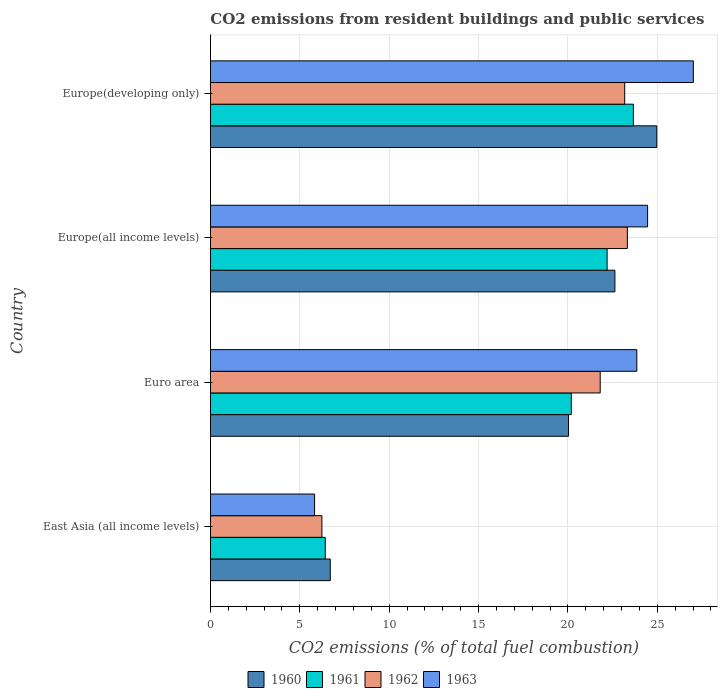How many groups of bars are there?
Provide a succinct answer. 4. Are the number of bars on each tick of the Y-axis equal?
Provide a short and direct response. Yes. What is the label of the 3rd group of bars from the top?
Make the answer very short. Euro area. What is the total CO2 emitted in 1961 in Europe(all income levels)?
Offer a terse response. 22.19. Across all countries, what is the maximum total CO2 emitted in 1963?
Make the answer very short. 27.01. Across all countries, what is the minimum total CO2 emitted in 1960?
Ensure brevity in your answer.  6.7. In which country was the total CO2 emitted in 1961 maximum?
Give a very brief answer. Europe(developing only). In which country was the total CO2 emitted in 1961 minimum?
Your response must be concise. East Asia (all income levels). What is the total total CO2 emitted in 1962 in the graph?
Offer a terse response. 74.53. What is the difference between the total CO2 emitted in 1960 in East Asia (all income levels) and that in Euro area?
Your response must be concise. -13.33. What is the difference between the total CO2 emitted in 1960 in Euro area and the total CO2 emitted in 1961 in Europe(developing only)?
Ensure brevity in your answer.  -3.63. What is the average total CO2 emitted in 1960 per country?
Provide a succinct answer. 18.58. What is the difference between the total CO2 emitted in 1960 and total CO2 emitted in 1962 in Europe(all income levels)?
Your response must be concise. -0.7. What is the ratio of the total CO2 emitted in 1960 in East Asia (all income levels) to that in Euro area?
Provide a short and direct response. 0.33. What is the difference between the highest and the second highest total CO2 emitted in 1961?
Offer a terse response. 1.47. What is the difference between the highest and the lowest total CO2 emitted in 1962?
Your response must be concise. 17.09. In how many countries, is the total CO2 emitted in 1963 greater than the average total CO2 emitted in 1963 taken over all countries?
Your response must be concise. 3. What does the 3rd bar from the top in Europe(all income levels) represents?
Offer a very short reply. 1961. How many bars are there?
Provide a succinct answer. 16. What is the difference between two consecutive major ticks on the X-axis?
Keep it short and to the point. 5. Are the values on the major ticks of X-axis written in scientific E-notation?
Offer a very short reply. No. Does the graph contain grids?
Offer a very short reply. Yes. Where does the legend appear in the graph?
Provide a succinct answer. Bottom center. How many legend labels are there?
Provide a succinct answer. 4. How are the legend labels stacked?
Keep it short and to the point. Horizontal. What is the title of the graph?
Offer a very short reply. CO2 emissions from resident buildings and public services. What is the label or title of the X-axis?
Your answer should be compact. CO2 emissions (% of total fuel combustion). What is the label or title of the Y-axis?
Your answer should be compact. Country. What is the CO2 emissions (% of total fuel combustion) of 1960 in East Asia (all income levels)?
Offer a very short reply. 6.7. What is the CO2 emissions (% of total fuel combustion) in 1961 in East Asia (all income levels)?
Offer a terse response. 6.42. What is the CO2 emissions (% of total fuel combustion) of 1962 in East Asia (all income levels)?
Make the answer very short. 6.23. What is the CO2 emissions (% of total fuel combustion) in 1963 in East Asia (all income levels)?
Your response must be concise. 5.82. What is the CO2 emissions (% of total fuel combustion) of 1960 in Euro area?
Give a very brief answer. 20.03. What is the CO2 emissions (% of total fuel combustion) of 1961 in Euro area?
Offer a terse response. 20.19. What is the CO2 emissions (% of total fuel combustion) in 1962 in Euro area?
Make the answer very short. 21.8. What is the CO2 emissions (% of total fuel combustion) in 1963 in Euro area?
Provide a short and direct response. 23.85. What is the CO2 emissions (% of total fuel combustion) in 1960 in Europe(all income levels)?
Offer a terse response. 22.63. What is the CO2 emissions (% of total fuel combustion) of 1961 in Europe(all income levels)?
Your answer should be compact. 22.19. What is the CO2 emissions (% of total fuel combustion) of 1962 in Europe(all income levels)?
Keep it short and to the point. 23.32. What is the CO2 emissions (% of total fuel combustion) of 1963 in Europe(all income levels)?
Provide a succinct answer. 24.45. What is the CO2 emissions (% of total fuel combustion) of 1960 in Europe(developing only)?
Ensure brevity in your answer.  24.97. What is the CO2 emissions (% of total fuel combustion) in 1961 in Europe(developing only)?
Your answer should be compact. 23.66. What is the CO2 emissions (% of total fuel combustion) in 1962 in Europe(developing only)?
Provide a short and direct response. 23.17. What is the CO2 emissions (% of total fuel combustion) of 1963 in Europe(developing only)?
Offer a very short reply. 27.01. Across all countries, what is the maximum CO2 emissions (% of total fuel combustion) of 1960?
Provide a succinct answer. 24.97. Across all countries, what is the maximum CO2 emissions (% of total fuel combustion) in 1961?
Your response must be concise. 23.66. Across all countries, what is the maximum CO2 emissions (% of total fuel combustion) of 1962?
Give a very brief answer. 23.32. Across all countries, what is the maximum CO2 emissions (% of total fuel combustion) of 1963?
Your answer should be very brief. 27.01. Across all countries, what is the minimum CO2 emissions (% of total fuel combustion) of 1960?
Your answer should be very brief. 6.7. Across all countries, what is the minimum CO2 emissions (% of total fuel combustion) in 1961?
Offer a terse response. 6.42. Across all countries, what is the minimum CO2 emissions (% of total fuel combustion) in 1962?
Ensure brevity in your answer.  6.23. Across all countries, what is the minimum CO2 emissions (% of total fuel combustion) in 1963?
Your answer should be very brief. 5.82. What is the total CO2 emissions (% of total fuel combustion) in 1960 in the graph?
Your answer should be compact. 74.33. What is the total CO2 emissions (% of total fuel combustion) in 1961 in the graph?
Give a very brief answer. 72.46. What is the total CO2 emissions (% of total fuel combustion) in 1962 in the graph?
Your answer should be very brief. 74.53. What is the total CO2 emissions (% of total fuel combustion) in 1963 in the graph?
Offer a terse response. 81.15. What is the difference between the CO2 emissions (% of total fuel combustion) in 1960 in East Asia (all income levels) and that in Euro area?
Make the answer very short. -13.33. What is the difference between the CO2 emissions (% of total fuel combustion) of 1961 in East Asia (all income levels) and that in Euro area?
Keep it short and to the point. -13.76. What is the difference between the CO2 emissions (% of total fuel combustion) in 1962 in East Asia (all income levels) and that in Euro area?
Ensure brevity in your answer.  -15.57. What is the difference between the CO2 emissions (% of total fuel combustion) in 1963 in East Asia (all income levels) and that in Euro area?
Keep it short and to the point. -18.03. What is the difference between the CO2 emissions (% of total fuel combustion) of 1960 in East Asia (all income levels) and that in Europe(all income levels)?
Your response must be concise. -15.92. What is the difference between the CO2 emissions (% of total fuel combustion) in 1961 in East Asia (all income levels) and that in Europe(all income levels)?
Provide a succinct answer. -15.77. What is the difference between the CO2 emissions (% of total fuel combustion) in 1962 in East Asia (all income levels) and that in Europe(all income levels)?
Provide a succinct answer. -17.09. What is the difference between the CO2 emissions (% of total fuel combustion) in 1963 in East Asia (all income levels) and that in Europe(all income levels)?
Your response must be concise. -18.63. What is the difference between the CO2 emissions (% of total fuel combustion) of 1960 in East Asia (all income levels) and that in Europe(developing only)?
Your answer should be very brief. -18.27. What is the difference between the CO2 emissions (% of total fuel combustion) in 1961 in East Asia (all income levels) and that in Europe(developing only)?
Keep it short and to the point. -17.24. What is the difference between the CO2 emissions (% of total fuel combustion) of 1962 in East Asia (all income levels) and that in Europe(developing only)?
Provide a short and direct response. -16.94. What is the difference between the CO2 emissions (% of total fuel combustion) of 1963 in East Asia (all income levels) and that in Europe(developing only)?
Keep it short and to the point. -21.19. What is the difference between the CO2 emissions (% of total fuel combustion) of 1960 in Euro area and that in Europe(all income levels)?
Your answer should be compact. -2.59. What is the difference between the CO2 emissions (% of total fuel combustion) in 1961 in Euro area and that in Europe(all income levels)?
Your answer should be very brief. -2. What is the difference between the CO2 emissions (% of total fuel combustion) of 1962 in Euro area and that in Europe(all income levels)?
Your answer should be very brief. -1.52. What is the difference between the CO2 emissions (% of total fuel combustion) in 1963 in Euro area and that in Europe(all income levels)?
Keep it short and to the point. -0.6. What is the difference between the CO2 emissions (% of total fuel combustion) of 1960 in Euro area and that in Europe(developing only)?
Provide a short and direct response. -4.94. What is the difference between the CO2 emissions (% of total fuel combustion) of 1961 in Euro area and that in Europe(developing only)?
Your response must be concise. -3.47. What is the difference between the CO2 emissions (% of total fuel combustion) of 1962 in Euro area and that in Europe(developing only)?
Give a very brief answer. -1.37. What is the difference between the CO2 emissions (% of total fuel combustion) in 1963 in Euro area and that in Europe(developing only)?
Ensure brevity in your answer.  -3.16. What is the difference between the CO2 emissions (% of total fuel combustion) of 1960 in Europe(all income levels) and that in Europe(developing only)?
Offer a terse response. -2.34. What is the difference between the CO2 emissions (% of total fuel combustion) in 1961 in Europe(all income levels) and that in Europe(developing only)?
Provide a short and direct response. -1.47. What is the difference between the CO2 emissions (% of total fuel combustion) in 1962 in Europe(all income levels) and that in Europe(developing only)?
Your answer should be compact. 0.15. What is the difference between the CO2 emissions (% of total fuel combustion) in 1963 in Europe(all income levels) and that in Europe(developing only)?
Give a very brief answer. -2.56. What is the difference between the CO2 emissions (% of total fuel combustion) in 1960 in East Asia (all income levels) and the CO2 emissions (% of total fuel combustion) in 1961 in Euro area?
Ensure brevity in your answer.  -13.48. What is the difference between the CO2 emissions (% of total fuel combustion) in 1960 in East Asia (all income levels) and the CO2 emissions (% of total fuel combustion) in 1962 in Euro area?
Your answer should be compact. -15.1. What is the difference between the CO2 emissions (% of total fuel combustion) of 1960 in East Asia (all income levels) and the CO2 emissions (% of total fuel combustion) of 1963 in Euro area?
Your answer should be compact. -17.15. What is the difference between the CO2 emissions (% of total fuel combustion) of 1961 in East Asia (all income levels) and the CO2 emissions (% of total fuel combustion) of 1962 in Euro area?
Provide a succinct answer. -15.38. What is the difference between the CO2 emissions (% of total fuel combustion) of 1961 in East Asia (all income levels) and the CO2 emissions (% of total fuel combustion) of 1963 in Euro area?
Offer a very short reply. -17.43. What is the difference between the CO2 emissions (% of total fuel combustion) of 1962 in East Asia (all income levels) and the CO2 emissions (% of total fuel combustion) of 1963 in Euro area?
Your response must be concise. -17.62. What is the difference between the CO2 emissions (% of total fuel combustion) of 1960 in East Asia (all income levels) and the CO2 emissions (% of total fuel combustion) of 1961 in Europe(all income levels)?
Make the answer very short. -15.49. What is the difference between the CO2 emissions (% of total fuel combustion) in 1960 in East Asia (all income levels) and the CO2 emissions (% of total fuel combustion) in 1962 in Europe(all income levels)?
Provide a short and direct response. -16.62. What is the difference between the CO2 emissions (% of total fuel combustion) of 1960 in East Asia (all income levels) and the CO2 emissions (% of total fuel combustion) of 1963 in Europe(all income levels)?
Ensure brevity in your answer.  -17.75. What is the difference between the CO2 emissions (% of total fuel combustion) in 1961 in East Asia (all income levels) and the CO2 emissions (% of total fuel combustion) in 1962 in Europe(all income levels)?
Your response must be concise. -16.9. What is the difference between the CO2 emissions (% of total fuel combustion) in 1961 in East Asia (all income levels) and the CO2 emissions (% of total fuel combustion) in 1963 in Europe(all income levels)?
Your response must be concise. -18.03. What is the difference between the CO2 emissions (% of total fuel combustion) of 1962 in East Asia (all income levels) and the CO2 emissions (% of total fuel combustion) of 1963 in Europe(all income levels)?
Provide a succinct answer. -18.22. What is the difference between the CO2 emissions (% of total fuel combustion) of 1960 in East Asia (all income levels) and the CO2 emissions (% of total fuel combustion) of 1961 in Europe(developing only)?
Give a very brief answer. -16.96. What is the difference between the CO2 emissions (% of total fuel combustion) in 1960 in East Asia (all income levels) and the CO2 emissions (% of total fuel combustion) in 1962 in Europe(developing only)?
Your answer should be compact. -16.47. What is the difference between the CO2 emissions (% of total fuel combustion) in 1960 in East Asia (all income levels) and the CO2 emissions (% of total fuel combustion) in 1963 in Europe(developing only)?
Your answer should be compact. -20.31. What is the difference between the CO2 emissions (% of total fuel combustion) in 1961 in East Asia (all income levels) and the CO2 emissions (% of total fuel combustion) in 1962 in Europe(developing only)?
Provide a succinct answer. -16.75. What is the difference between the CO2 emissions (% of total fuel combustion) of 1961 in East Asia (all income levels) and the CO2 emissions (% of total fuel combustion) of 1963 in Europe(developing only)?
Your answer should be very brief. -20.59. What is the difference between the CO2 emissions (% of total fuel combustion) in 1962 in East Asia (all income levels) and the CO2 emissions (% of total fuel combustion) in 1963 in Europe(developing only)?
Your response must be concise. -20.78. What is the difference between the CO2 emissions (% of total fuel combustion) in 1960 in Euro area and the CO2 emissions (% of total fuel combustion) in 1961 in Europe(all income levels)?
Make the answer very short. -2.16. What is the difference between the CO2 emissions (% of total fuel combustion) in 1960 in Euro area and the CO2 emissions (% of total fuel combustion) in 1962 in Europe(all income levels)?
Your answer should be very brief. -3.29. What is the difference between the CO2 emissions (% of total fuel combustion) in 1960 in Euro area and the CO2 emissions (% of total fuel combustion) in 1963 in Europe(all income levels)?
Your answer should be very brief. -4.42. What is the difference between the CO2 emissions (% of total fuel combustion) of 1961 in Euro area and the CO2 emissions (% of total fuel combustion) of 1962 in Europe(all income levels)?
Offer a terse response. -3.14. What is the difference between the CO2 emissions (% of total fuel combustion) of 1961 in Euro area and the CO2 emissions (% of total fuel combustion) of 1963 in Europe(all income levels)?
Your answer should be very brief. -4.27. What is the difference between the CO2 emissions (% of total fuel combustion) in 1962 in Euro area and the CO2 emissions (% of total fuel combustion) in 1963 in Europe(all income levels)?
Offer a very short reply. -2.65. What is the difference between the CO2 emissions (% of total fuel combustion) of 1960 in Euro area and the CO2 emissions (% of total fuel combustion) of 1961 in Europe(developing only)?
Keep it short and to the point. -3.63. What is the difference between the CO2 emissions (% of total fuel combustion) of 1960 in Euro area and the CO2 emissions (% of total fuel combustion) of 1962 in Europe(developing only)?
Offer a very short reply. -3.14. What is the difference between the CO2 emissions (% of total fuel combustion) of 1960 in Euro area and the CO2 emissions (% of total fuel combustion) of 1963 in Europe(developing only)?
Provide a short and direct response. -6.98. What is the difference between the CO2 emissions (% of total fuel combustion) of 1961 in Euro area and the CO2 emissions (% of total fuel combustion) of 1962 in Europe(developing only)?
Keep it short and to the point. -2.99. What is the difference between the CO2 emissions (% of total fuel combustion) of 1961 in Euro area and the CO2 emissions (% of total fuel combustion) of 1963 in Europe(developing only)?
Offer a very short reply. -6.83. What is the difference between the CO2 emissions (% of total fuel combustion) in 1962 in Euro area and the CO2 emissions (% of total fuel combustion) in 1963 in Europe(developing only)?
Your answer should be compact. -5.21. What is the difference between the CO2 emissions (% of total fuel combustion) of 1960 in Europe(all income levels) and the CO2 emissions (% of total fuel combustion) of 1961 in Europe(developing only)?
Your answer should be very brief. -1.03. What is the difference between the CO2 emissions (% of total fuel combustion) of 1960 in Europe(all income levels) and the CO2 emissions (% of total fuel combustion) of 1962 in Europe(developing only)?
Your response must be concise. -0.55. What is the difference between the CO2 emissions (% of total fuel combustion) in 1960 in Europe(all income levels) and the CO2 emissions (% of total fuel combustion) in 1963 in Europe(developing only)?
Offer a terse response. -4.39. What is the difference between the CO2 emissions (% of total fuel combustion) of 1961 in Europe(all income levels) and the CO2 emissions (% of total fuel combustion) of 1962 in Europe(developing only)?
Your response must be concise. -0.98. What is the difference between the CO2 emissions (% of total fuel combustion) in 1961 in Europe(all income levels) and the CO2 emissions (% of total fuel combustion) in 1963 in Europe(developing only)?
Offer a very short reply. -4.82. What is the difference between the CO2 emissions (% of total fuel combustion) of 1962 in Europe(all income levels) and the CO2 emissions (% of total fuel combustion) of 1963 in Europe(developing only)?
Provide a succinct answer. -3.69. What is the average CO2 emissions (% of total fuel combustion) of 1960 per country?
Offer a terse response. 18.58. What is the average CO2 emissions (% of total fuel combustion) of 1961 per country?
Your response must be concise. 18.11. What is the average CO2 emissions (% of total fuel combustion) of 1962 per country?
Make the answer very short. 18.63. What is the average CO2 emissions (% of total fuel combustion) of 1963 per country?
Ensure brevity in your answer.  20.29. What is the difference between the CO2 emissions (% of total fuel combustion) of 1960 and CO2 emissions (% of total fuel combustion) of 1961 in East Asia (all income levels)?
Make the answer very short. 0.28. What is the difference between the CO2 emissions (% of total fuel combustion) of 1960 and CO2 emissions (% of total fuel combustion) of 1962 in East Asia (all income levels)?
Ensure brevity in your answer.  0.47. What is the difference between the CO2 emissions (% of total fuel combustion) in 1960 and CO2 emissions (% of total fuel combustion) in 1963 in East Asia (all income levels)?
Offer a terse response. 0.88. What is the difference between the CO2 emissions (% of total fuel combustion) in 1961 and CO2 emissions (% of total fuel combustion) in 1962 in East Asia (all income levels)?
Keep it short and to the point. 0.19. What is the difference between the CO2 emissions (% of total fuel combustion) of 1961 and CO2 emissions (% of total fuel combustion) of 1963 in East Asia (all income levels)?
Your answer should be compact. 0.6. What is the difference between the CO2 emissions (% of total fuel combustion) in 1962 and CO2 emissions (% of total fuel combustion) in 1963 in East Asia (all income levels)?
Make the answer very short. 0.41. What is the difference between the CO2 emissions (% of total fuel combustion) of 1960 and CO2 emissions (% of total fuel combustion) of 1961 in Euro area?
Offer a very short reply. -0.15. What is the difference between the CO2 emissions (% of total fuel combustion) of 1960 and CO2 emissions (% of total fuel combustion) of 1962 in Euro area?
Your answer should be compact. -1.77. What is the difference between the CO2 emissions (% of total fuel combustion) of 1960 and CO2 emissions (% of total fuel combustion) of 1963 in Euro area?
Offer a terse response. -3.82. What is the difference between the CO2 emissions (% of total fuel combustion) in 1961 and CO2 emissions (% of total fuel combustion) in 1962 in Euro area?
Give a very brief answer. -1.62. What is the difference between the CO2 emissions (% of total fuel combustion) in 1961 and CO2 emissions (% of total fuel combustion) in 1963 in Euro area?
Your answer should be very brief. -3.66. What is the difference between the CO2 emissions (% of total fuel combustion) in 1962 and CO2 emissions (% of total fuel combustion) in 1963 in Euro area?
Give a very brief answer. -2.05. What is the difference between the CO2 emissions (% of total fuel combustion) of 1960 and CO2 emissions (% of total fuel combustion) of 1961 in Europe(all income levels)?
Keep it short and to the point. 0.44. What is the difference between the CO2 emissions (% of total fuel combustion) of 1960 and CO2 emissions (% of total fuel combustion) of 1962 in Europe(all income levels)?
Ensure brevity in your answer.  -0.7. What is the difference between the CO2 emissions (% of total fuel combustion) of 1960 and CO2 emissions (% of total fuel combustion) of 1963 in Europe(all income levels)?
Ensure brevity in your answer.  -1.83. What is the difference between the CO2 emissions (% of total fuel combustion) in 1961 and CO2 emissions (% of total fuel combustion) in 1962 in Europe(all income levels)?
Keep it short and to the point. -1.13. What is the difference between the CO2 emissions (% of total fuel combustion) of 1961 and CO2 emissions (% of total fuel combustion) of 1963 in Europe(all income levels)?
Your answer should be compact. -2.26. What is the difference between the CO2 emissions (% of total fuel combustion) of 1962 and CO2 emissions (% of total fuel combustion) of 1963 in Europe(all income levels)?
Ensure brevity in your answer.  -1.13. What is the difference between the CO2 emissions (% of total fuel combustion) in 1960 and CO2 emissions (% of total fuel combustion) in 1961 in Europe(developing only)?
Your response must be concise. 1.31. What is the difference between the CO2 emissions (% of total fuel combustion) of 1960 and CO2 emissions (% of total fuel combustion) of 1962 in Europe(developing only)?
Provide a succinct answer. 1.8. What is the difference between the CO2 emissions (% of total fuel combustion) of 1960 and CO2 emissions (% of total fuel combustion) of 1963 in Europe(developing only)?
Ensure brevity in your answer.  -2.05. What is the difference between the CO2 emissions (% of total fuel combustion) of 1961 and CO2 emissions (% of total fuel combustion) of 1962 in Europe(developing only)?
Offer a very short reply. 0.49. What is the difference between the CO2 emissions (% of total fuel combustion) in 1961 and CO2 emissions (% of total fuel combustion) in 1963 in Europe(developing only)?
Provide a succinct answer. -3.35. What is the difference between the CO2 emissions (% of total fuel combustion) in 1962 and CO2 emissions (% of total fuel combustion) in 1963 in Europe(developing only)?
Make the answer very short. -3.84. What is the ratio of the CO2 emissions (% of total fuel combustion) in 1960 in East Asia (all income levels) to that in Euro area?
Keep it short and to the point. 0.33. What is the ratio of the CO2 emissions (% of total fuel combustion) in 1961 in East Asia (all income levels) to that in Euro area?
Provide a succinct answer. 0.32. What is the ratio of the CO2 emissions (% of total fuel combustion) of 1962 in East Asia (all income levels) to that in Euro area?
Your answer should be very brief. 0.29. What is the ratio of the CO2 emissions (% of total fuel combustion) in 1963 in East Asia (all income levels) to that in Euro area?
Provide a short and direct response. 0.24. What is the ratio of the CO2 emissions (% of total fuel combustion) in 1960 in East Asia (all income levels) to that in Europe(all income levels)?
Your answer should be very brief. 0.3. What is the ratio of the CO2 emissions (% of total fuel combustion) of 1961 in East Asia (all income levels) to that in Europe(all income levels)?
Provide a succinct answer. 0.29. What is the ratio of the CO2 emissions (% of total fuel combustion) in 1962 in East Asia (all income levels) to that in Europe(all income levels)?
Keep it short and to the point. 0.27. What is the ratio of the CO2 emissions (% of total fuel combustion) of 1963 in East Asia (all income levels) to that in Europe(all income levels)?
Ensure brevity in your answer.  0.24. What is the ratio of the CO2 emissions (% of total fuel combustion) in 1960 in East Asia (all income levels) to that in Europe(developing only)?
Make the answer very short. 0.27. What is the ratio of the CO2 emissions (% of total fuel combustion) of 1961 in East Asia (all income levels) to that in Europe(developing only)?
Keep it short and to the point. 0.27. What is the ratio of the CO2 emissions (% of total fuel combustion) in 1962 in East Asia (all income levels) to that in Europe(developing only)?
Give a very brief answer. 0.27. What is the ratio of the CO2 emissions (% of total fuel combustion) of 1963 in East Asia (all income levels) to that in Europe(developing only)?
Ensure brevity in your answer.  0.22. What is the ratio of the CO2 emissions (% of total fuel combustion) of 1960 in Euro area to that in Europe(all income levels)?
Provide a succinct answer. 0.89. What is the ratio of the CO2 emissions (% of total fuel combustion) in 1961 in Euro area to that in Europe(all income levels)?
Your response must be concise. 0.91. What is the ratio of the CO2 emissions (% of total fuel combustion) in 1962 in Euro area to that in Europe(all income levels)?
Offer a terse response. 0.93. What is the ratio of the CO2 emissions (% of total fuel combustion) of 1963 in Euro area to that in Europe(all income levels)?
Give a very brief answer. 0.98. What is the ratio of the CO2 emissions (% of total fuel combustion) of 1960 in Euro area to that in Europe(developing only)?
Provide a short and direct response. 0.8. What is the ratio of the CO2 emissions (% of total fuel combustion) in 1961 in Euro area to that in Europe(developing only)?
Provide a succinct answer. 0.85. What is the ratio of the CO2 emissions (% of total fuel combustion) of 1962 in Euro area to that in Europe(developing only)?
Offer a very short reply. 0.94. What is the ratio of the CO2 emissions (% of total fuel combustion) of 1963 in Euro area to that in Europe(developing only)?
Your answer should be very brief. 0.88. What is the ratio of the CO2 emissions (% of total fuel combustion) of 1960 in Europe(all income levels) to that in Europe(developing only)?
Your answer should be very brief. 0.91. What is the ratio of the CO2 emissions (% of total fuel combustion) of 1961 in Europe(all income levels) to that in Europe(developing only)?
Offer a terse response. 0.94. What is the ratio of the CO2 emissions (% of total fuel combustion) in 1963 in Europe(all income levels) to that in Europe(developing only)?
Offer a very short reply. 0.91. What is the difference between the highest and the second highest CO2 emissions (% of total fuel combustion) of 1960?
Your answer should be compact. 2.34. What is the difference between the highest and the second highest CO2 emissions (% of total fuel combustion) in 1961?
Make the answer very short. 1.47. What is the difference between the highest and the second highest CO2 emissions (% of total fuel combustion) in 1962?
Keep it short and to the point. 0.15. What is the difference between the highest and the second highest CO2 emissions (% of total fuel combustion) in 1963?
Your answer should be very brief. 2.56. What is the difference between the highest and the lowest CO2 emissions (% of total fuel combustion) of 1960?
Offer a very short reply. 18.27. What is the difference between the highest and the lowest CO2 emissions (% of total fuel combustion) in 1961?
Keep it short and to the point. 17.24. What is the difference between the highest and the lowest CO2 emissions (% of total fuel combustion) of 1962?
Offer a terse response. 17.09. What is the difference between the highest and the lowest CO2 emissions (% of total fuel combustion) of 1963?
Offer a terse response. 21.19. 